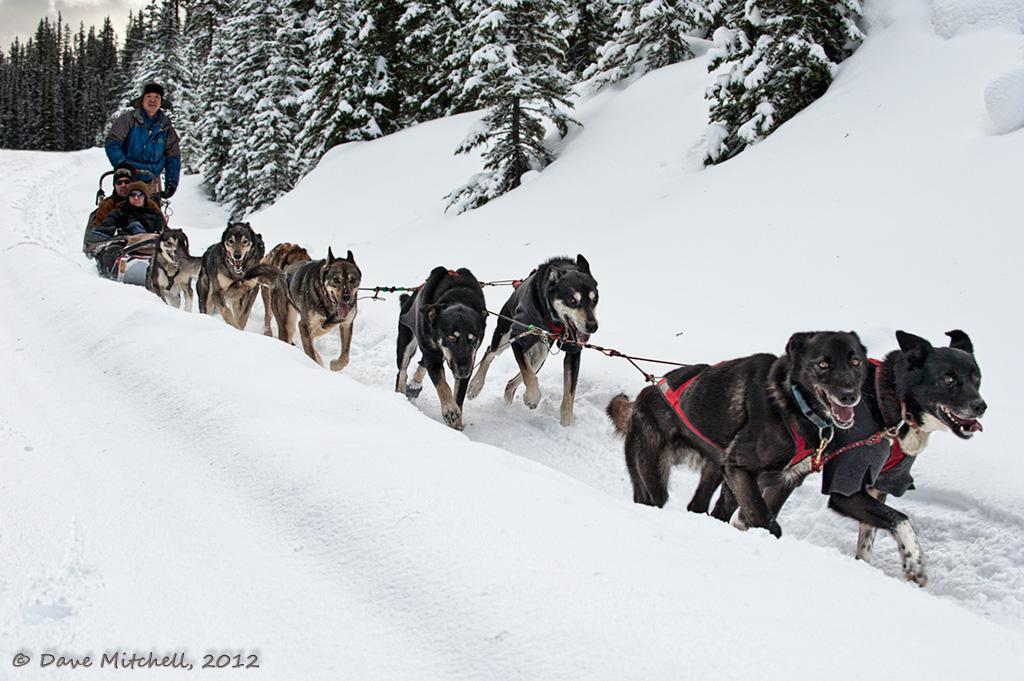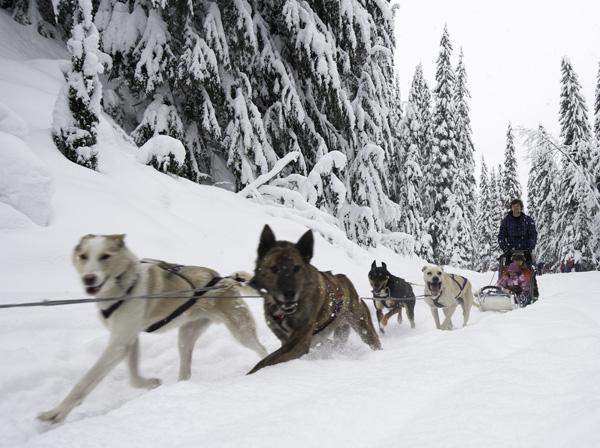The first image is the image on the left, the second image is the image on the right. Considering the images on both sides, is "The left image contains no more than six sled dogs." valid? Answer yes or no. No. The first image is the image on the left, the second image is the image on the right. For the images displayed, is the sentence "The righthand dog sled team heads straight toward the camera, and the lefthand team heads at a diagonal to the right." factually correct? Answer yes or no. No. 